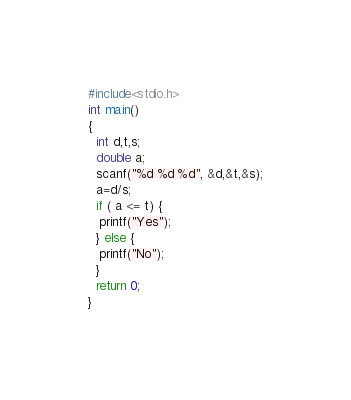Convert code to text. <code><loc_0><loc_0><loc_500><loc_500><_C_>#include<stdio.h>
int main()
{
  int d,t,s;
  double a;
  scanf("%d %d %d", &d,&t,&s);
  a=d/s;
  if ( a <= t) {
   printf("Yes"); 
  } else {
   printf("No");
  }
  return 0;
}</code> 